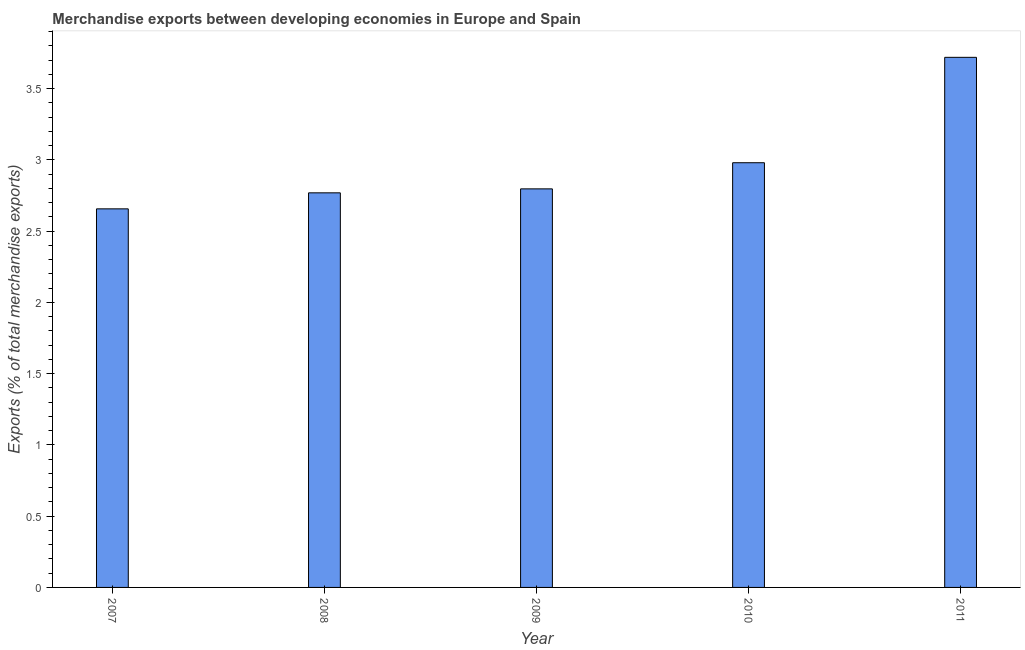Does the graph contain any zero values?
Make the answer very short. No. Does the graph contain grids?
Give a very brief answer. No. What is the title of the graph?
Provide a succinct answer. Merchandise exports between developing economies in Europe and Spain. What is the label or title of the X-axis?
Your answer should be compact. Year. What is the label or title of the Y-axis?
Your response must be concise. Exports (% of total merchandise exports). What is the merchandise exports in 2007?
Offer a very short reply. 2.66. Across all years, what is the maximum merchandise exports?
Give a very brief answer. 3.72. Across all years, what is the minimum merchandise exports?
Provide a succinct answer. 2.66. In which year was the merchandise exports maximum?
Provide a succinct answer. 2011. In which year was the merchandise exports minimum?
Give a very brief answer. 2007. What is the sum of the merchandise exports?
Make the answer very short. 14.92. What is the difference between the merchandise exports in 2010 and 2011?
Your response must be concise. -0.74. What is the average merchandise exports per year?
Your response must be concise. 2.98. What is the median merchandise exports?
Your answer should be compact. 2.8. Do a majority of the years between 2009 and 2011 (inclusive) have merchandise exports greater than 1.6 %?
Offer a terse response. Yes. Is the merchandise exports in 2007 less than that in 2008?
Give a very brief answer. Yes. Is the difference between the merchandise exports in 2007 and 2011 greater than the difference between any two years?
Your response must be concise. Yes. What is the difference between the highest and the second highest merchandise exports?
Your answer should be compact. 0.74. Is the sum of the merchandise exports in 2009 and 2011 greater than the maximum merchandise exports across all years?
Provide a succinct answer. Yes. What is the difference between the highest and the lowest merchandise exports?
Offer a very short reply. 1.06. In how many years, is the merchandise exports greater than the average merchandise exports taken over all years?
Your response must be concise. 1. How many years are there in the graph?
Make the answer very short. 5. Are the values on the major ticks of Y-axis written in scientific E-notation?
Your answer should be compact. No. What is the Exports (% of total merchandise exports) of 2007?
Provide a short and direct response. 2.66. What is the Exports (% of total merchandise exports) in 2008?
Offer a very short reply. 2.77. What is the Exports (% of total merchandise exports) of 2009?
Provide a short and direct response. 2.8. What is the Exports (% of total merchandise exports) in 2010?
Provide a short and direct response. 2.98. What is the Exports (% of total merchandise exports) of 2011?
Offer a terse response. 3.72. What is the difference between the Exports (% of total merchandise exports) in 2007 and 2008?
Offer a very short reply. -0.11. What is the difference between the Exports (% of total merchandise exports) in 2007 and 2009?
Provide a succinct answer. -0.14. What is the difference between the Exports (% of total merchandise exports) in 2007 and 2010?
Provide a short and direct response. -0.32. What is the difference between the Exports (% of total merchandise exports) in 2007 and 2011?
Provide a short and direct response. -1.06. What is the difference between the Exports (% of total merchandise exports) in 2008 and 2009?
Ensure brevity in your answer.  -0.03. What is the difference between the Exports (% of total merchandise exports) in 2008 and 2010?
Your answer should be very brief. -0.21. What is the difference between the Exports (% of total merchandise exports) in 2008 and 2011?
Ensure brevity in your answer.  -0.95. What is the difference between the Exports (% of total merchandise exports) in 2009 and 2010?
Your response must be concise. -0.18. What is the difference between the Exports (% of total merchandise exports) in 2009 and 2011?
Make the answer very short. -0.92. What is the difference between the Exports (% of total merchandise exports) in 2010 and 2011?
Give a very brief answer. -0.74. What is the ratio of the Exports (% of total merchandise exports) in 2007 to that in 2010?
Make the answer very short. 0.89. What is the ratio of the Exports (% of total merchandise exports) in 2007 to that in 2011?
Provide a short and direct response. 0.71. What is the ratio of the Exports (% of total merchandise exports) in 2008 to that in 2010?
Offer a very short reply. 0.93. What is the ratio of the Exports (% of total merchandise exports) in 2008 to that in 2011?
Your answer should be very brief. 0.74. What is the ratio of the Exports (% of total merchandise exports) in 2009 to that in 2010?
Offer a very short reply. 0.94. What is the ratio of the Exports (% of total merchandise exports) in 2009 to that in 2011?
Ensure brevity in your answer.  0.75. What is the ratio of the Exports (% of total merchandise exports) in 2010 to that in 2011?
Provide a succinct answer. 0.8. 